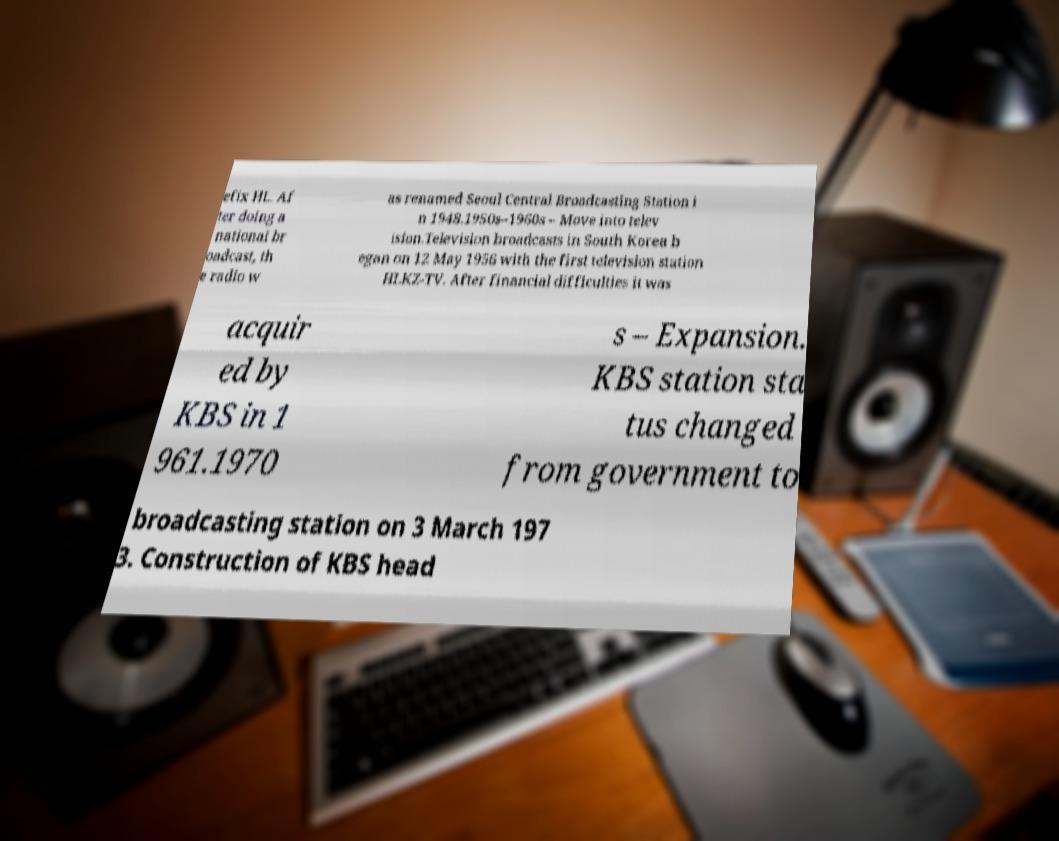Can you read and provide the text displayed in the image?This photo seems to have some interesting text. Can you extract and type it out for me? efix HL. Af ter doing a national br oadcast, th e radio w as renamed Seoul Central Broadcasting Station i n 1948.1950s–1960s – Move into telev ision.Television broadcasts in South Korea b egan on 12 May 1956 with the first television station HLKZ-TV. After financial difficulties it was acquir ed by KBS in 1 961.1970 s – Expansion. KBS station sta tus changed from government to broadcasting station on 3 March 197 3. Construction of KBS head 